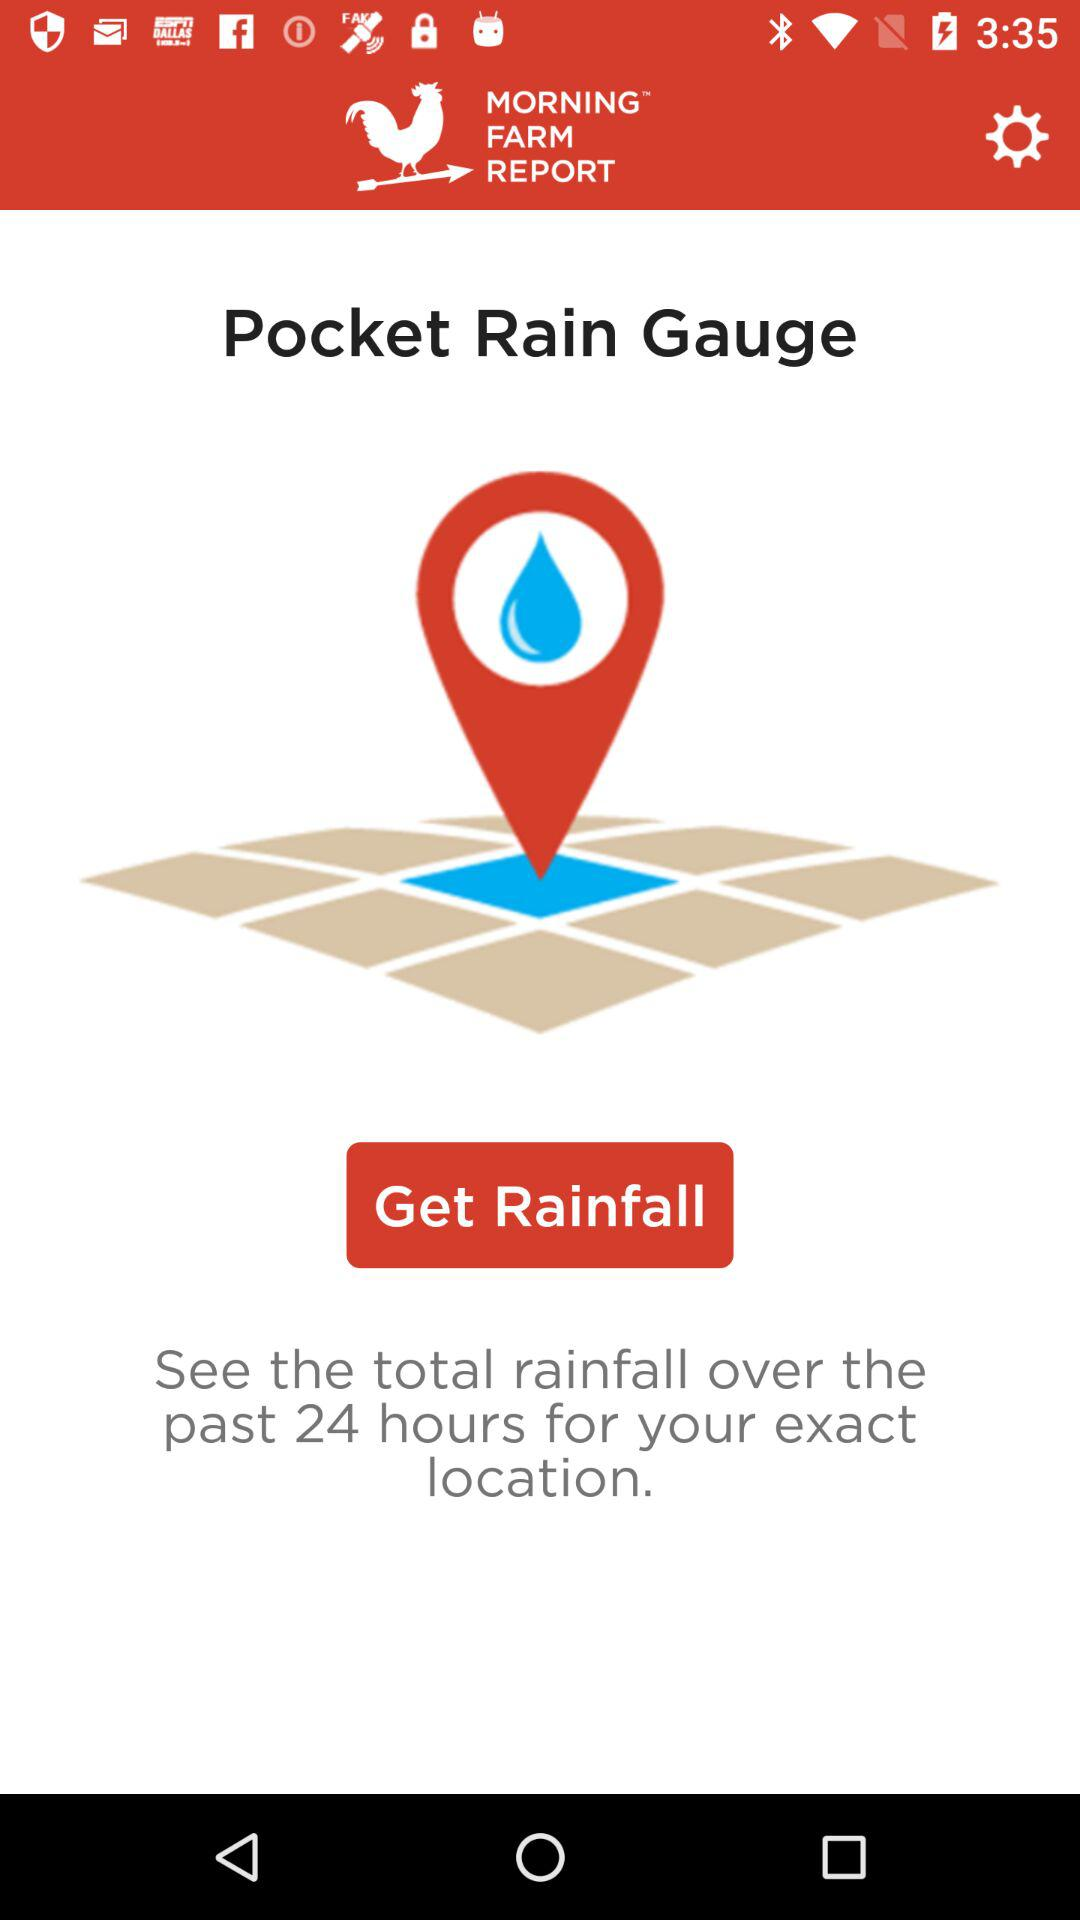How many hours of rainfall data can be seen for the exact location? For the exact location, 24 hours of rainfall data can be seen. 